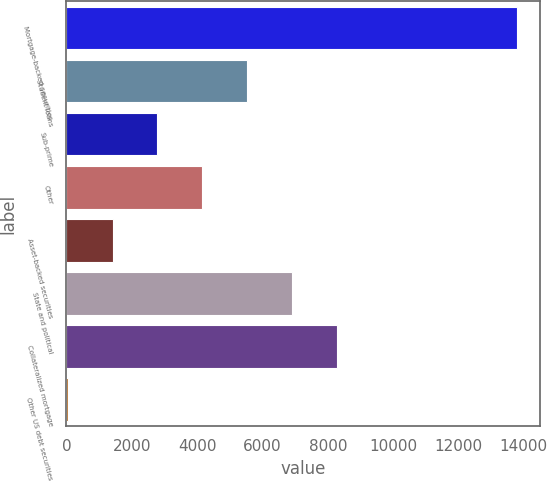Convert chart. <chart><loc_0><loc_0><loc_500><loc_500><bar_chart><fcel>Mortgage-backed securities<fcel>Student loans<fcel>Sub-prime<fcel>Other<fcel>Asset-backed securities<fcel>State and political<fcel>Collateralized mortgage<fcel>Other US debt securities<nl><fcel>13797<fcel>5539.2<fcel>2786.6<fcel>4162.9<fcel>1410.3<fcel>6915.5<fcel>8291.8<fcel>34<nl></chart> 